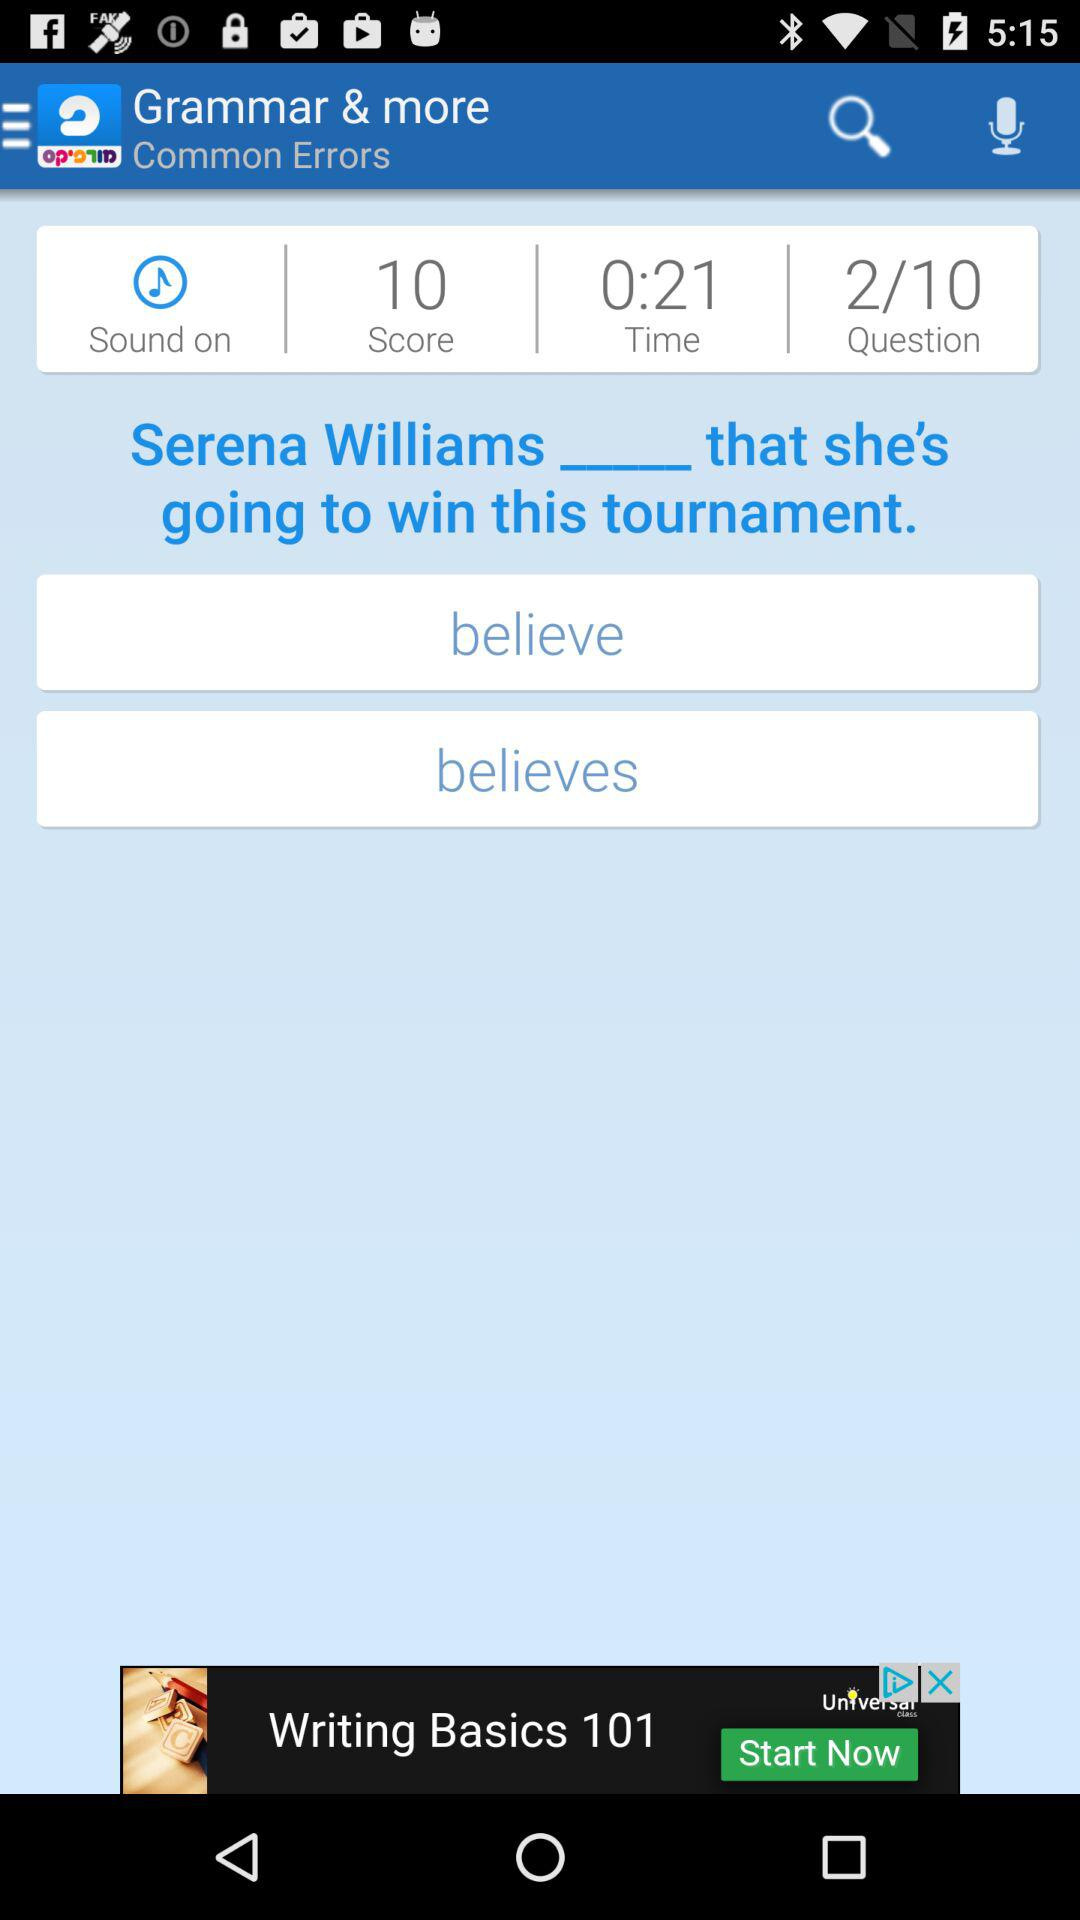How much time is left to answer? The time left to answer is 0:21. 